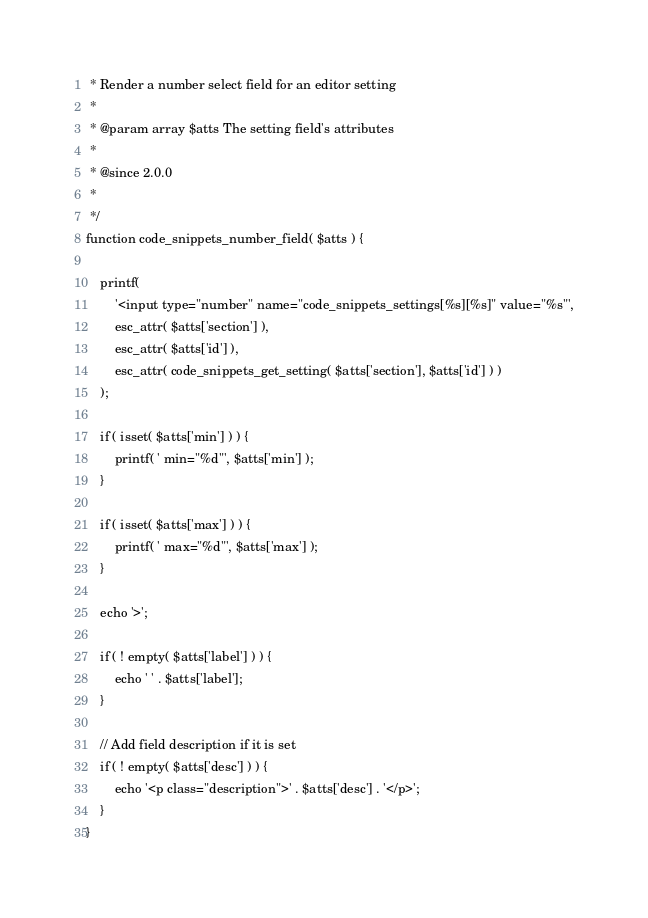Convert code to text. <code><loc_0><loc_0><loc_500><loc_500><_PHP_> * Render a number select field for an editor setting
 *
 * @param array $atts The setting field's attributes
 *
 * @since 2.0.0
 *
 */
function code_snippets_number_field( $atts ) {

	printf(
		'<input type="number" name="code_snippets_settings[%s][%s]" value="%s"',
		esc_attr( $atts['section'] ),
		esc_attr( $atts['id'] ),
		esc_attr( code_snippets_get_setting( $atts['section'], $atts['id'] ) )
	);

	if ( isset( $atts['min'] ) ) {
		printf( ' min="%d"', $atts['min'] );
	}

	if ( isset( $atts['max'] ) ) {
		printf( ' max="%d"', $atts['max'] );
	}

	echo '>';

	if ( ! empty( $atts['label'] ) ) {
		echo ' ' . $atts['label'];
	}

	// Add field description if it is set
	if ( ! empty( $atts['desc'] ) ) {
		echo '<p class="description">' . $atts['desc'] . '</p>';
	}
}
</code> 